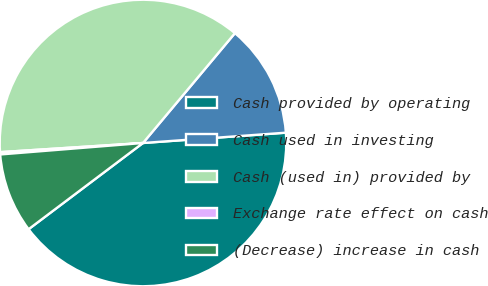Convert chart to OTSL. <chart><loc_0><loc_0><loc_500><loc_500><pie_chart><fcel>Cash provided by operating<fcel>Cash used in investing<fcel>Cash (used in) provided by<fcel>Exchange rate effect on cash<fcel>(Decrease) increase in cash<nl><fcel>40.87%<fcel>12.76%<fcel>37.11%<fcel>0.26%<fcel>9.0%<nl></chart> 